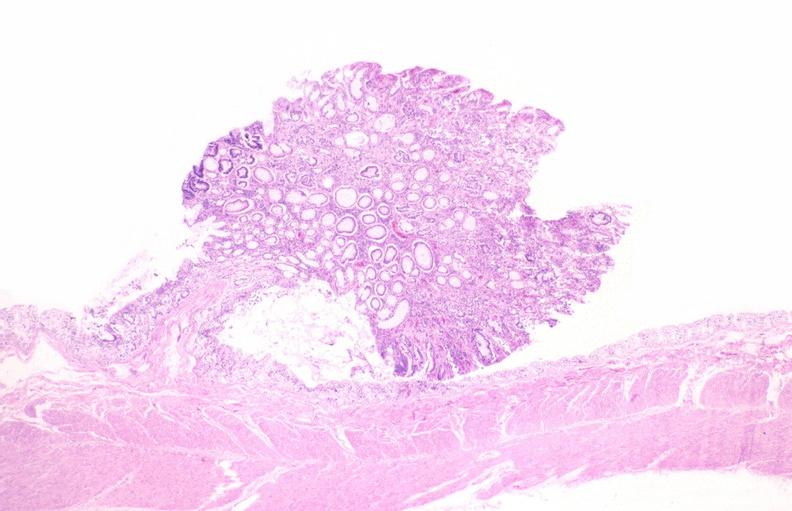does notochord show colon, adenomatous polyp?
Answer the question using a single word or phrase. No 